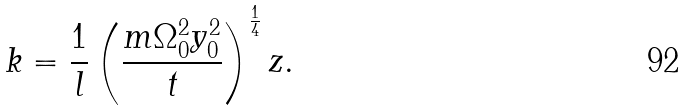Convert formula to latex. <formula><loc_0><loc_0><loc_500><loc_500>k = \frac { 1 } { l } \left ( \frac { m \Omega _ { 0 } ^ { 2 } y _ { 0 } ^ { 2 } } { t } \right ) ^ { \frac { 1 } { 4 } } z .</formula> 